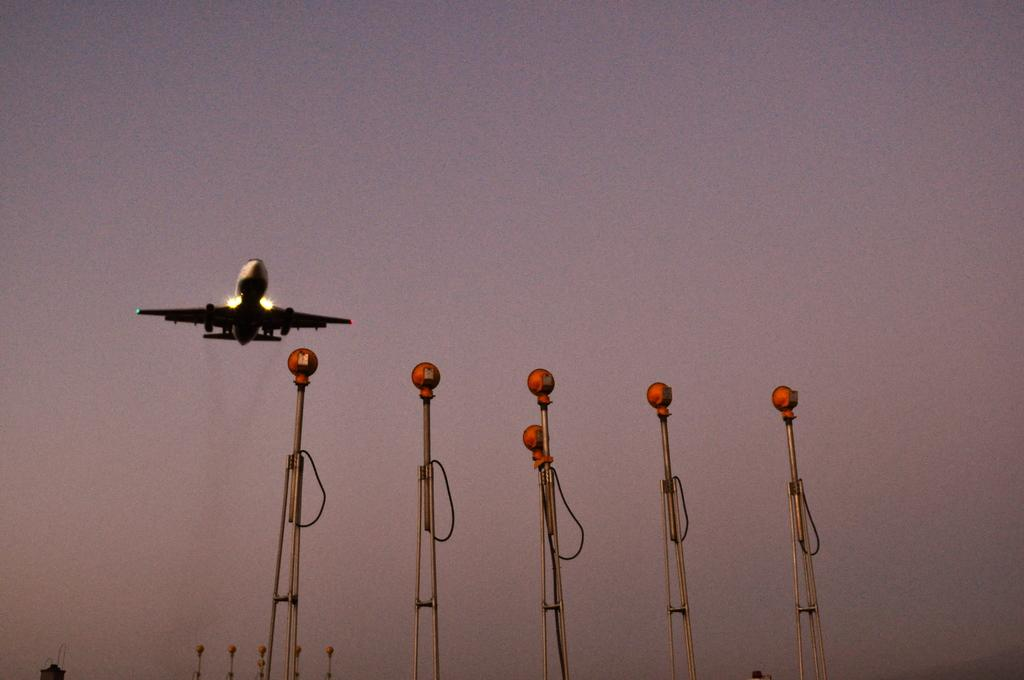What type of lighting is present in the image? There are pole lights in the image. What is happening in the sky in the image? The sky is cloudy in the image. What can be seen flying in the image? There is an airplane flying in the image. What type of animals can be seen at the zoo in the image? There is no zoo present in the image, so it is not possible to determine what type of animals might be seen there. 